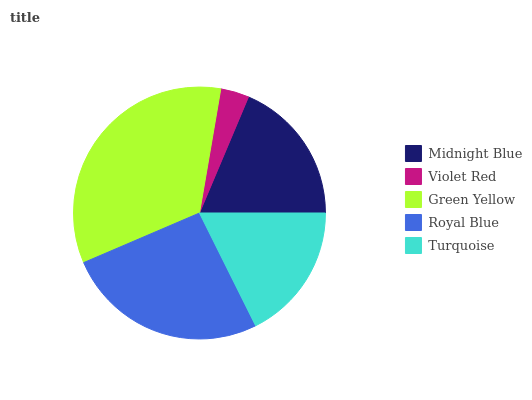Is Violet Red the minimum?
Answer yes or no. Yes. Is Green Yellow the maximum?
Answer yes or no. Yes. Is Green Yellow the minimum?
Answer yes or no. No. Is Violet Red the maximum?
Answer yes or no. No. Is Green Yellow greater than Violet Red?
Answer yes or no. Yes. Is Violet Red less than Green Yellow?
Answer yes or no. Yes. Is Violet Red greater than Green Yellow?
Answer yes or no. No. Is Green Yellow less than Violet Red?
Answer yes or no. No. Is Midnight Blue the high median?
Answer yes or no. Yes. Is Midnight Blue the low median?
Answer yes or no. Yes. Is Green Yellow the high median?
Answer yes or no. No. Is Violet Red the low median?
Answer yes or no. No. 